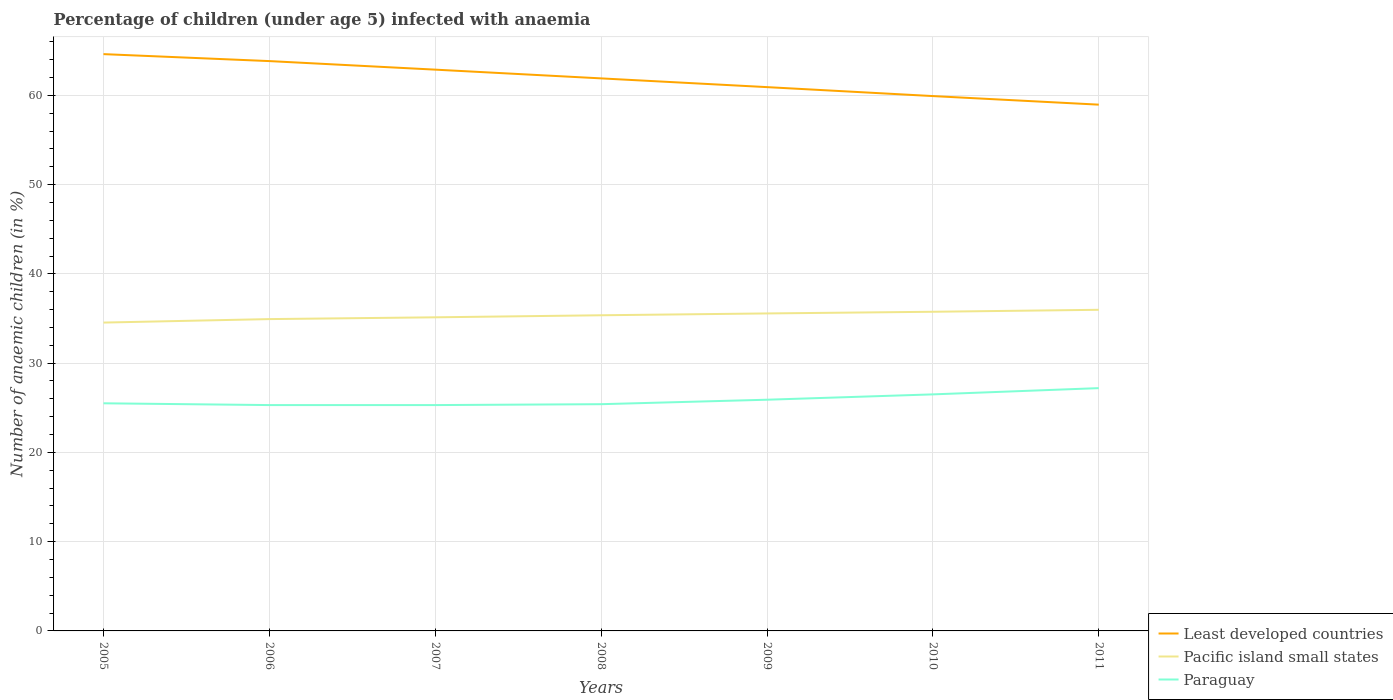How many different coloured lines are there?
Your response must be concise. 3. Does the line corresponding to Pacific island small states intersect with the line corresponding to Paraguay?
Offer a very short reply. No. Is the number of lines equal to the number of legend labels?
Make the answer very short. Yes. Across all years, what is the maximum percentage of children infected with anaemia in in Least developed countries?
Give a very brief answer. 58.96. In which year was the percentage of children infected with anaemia in in Pacific island small states maximum?
Provide a short and direct response. 2005. What is the total percentage of children infected with anaemia in in Paraguay in the graph?
Give a very brief answer. -0.1. What is the difference between the highest and the second highest percentage of children infected with anaemia in in Least developed countries?
Your answer should be compact. 5.66. What is the difference between the highest and the lowest percentage of children infected with anaemia in in Least developed countries?
Make the answer very short. 4. How many lines are there?
Provide a short and direct response. 3. How many years are there in the graph?
Your answer should be compact. 7. What is the difference between two consecutive major ticks on the Y-axis?
Provide a succinct answer. 10. Are the values on the major ticks of Y-axis written in scientific E-notation?
Provide a succinct answer. No. Does the graph contain any zero values?
Make the answer very short. No. Does the graph contain grids?
Your response must be concise. Yes. How many legend labels are there?
Provide a succinct answer. 3. What is the title of the graph?
Your response must be concise. Percentage of children (under age 5) infected with anaemia. Does "Barbados" appear as one of the legend labels in the graph?
Give a very brief answer. No. What is the label or title of the Y-axis?
Offer a very short reply. Number of anaemic children (in %). What is the Number of anaemic children (in %) of Least developed countries in 2005?
Provide a short and direct response. 64.62. What is the Number of anaemic children (in %) of Pacific island small states in 2005?
Your response must be concise. 34.54. What is the Number of anaemic children (in %) of Least developed countries in 2006?
Offer a very short reply. 63.84. What is the Number of anaemic children (in %) of Pacific island small states in 2006?
Make the answer very short. 34.93. What is the Number of anaemic children (in %) in Paraguay in 2006?
Your response must be concise. 25.3. What is the Number of anaemic children (in %) of Least developed countries in 2007?
Your response must be concise. 62.88. What is the Number of anaemic children (in %) in Pacific island small states in 2007?
Offer a very short reply. 35.13. What is the Number of anaemic children (in %) of Paraguay in 2007?
Your answer should be compact. 25.3. What is the Number of anaemic children (in %) of Least developed countries in 2008?
Keep it short and to the point. 61.9. What is the Number of anaemic children (in %) in Pacific island small states in 2008?
Give a very brief answer. 35.36. What is the Number of anaemic children (in %) of Paraguay in 2008?
Your answer should be very brief. 25.4. What is the Number of anaemic children (in %) of Least developed countries in 2009?
Your answer should be compact. 60.92. What is the Number of anaemic children (in %) in Pacific island small states in 2009?
Ensure brevity in your answer.  35.57. What is the Number of anaemic children (in %) in Paraguay in 2009?
Provide a short and direct response. 25.9. What is the Number of anaemic children (in %) in Least developed countries in 2010?
Ensure brevity in your answer.  59.92. What is the Number of anaemic children (in %) of Pacific island small states in 2010?
Your answer should be compact. 35.75. What is the Number of anaemic children (in %) of Paraguay in 2010?
Ensure brevity in your answer.  26.5. What is the Number of anaemic children (in %) of Least developed countries in 2011?
Give a very brief answer. 58.96. What is the Number of anaemic children (in %) in Pacific island small states in 2011?
Provide a short and direct response. 35.97. What is the Number of anaemic children (in %) of Paraguay in 2011?
Your answer should be very brief. 27.2. Across all years, what is the maximum Number of anaemic children (in %) in Least developed countries?
Make the answer very short. 64.62. Across all years, what is the maximum Number of anaemic children (in %) in Pacific island small states?
Ensure brevity in your answer.  35.97. Across all years, what is the maximum Number of anaemic children (in %) of Paraguay?
Your response must be concise. 27.2. Across all years, what is the minimum Number of anaemic children (in %) in Least developed countries?
Provide a short and direct response. 58.96. Across all years, what is the minimum Number of anaemic children (in %) of Pacific island small states?
Provide a succinct answer. 34.54. Across all years, what is the minimum Number of anaemic children (in %) in Paraguay?
Ensure brevity in your answer.  25.3. What is the total Number of anaemic children (in %) of Least developed countries in the graph?
Offer a very short reply. 433.02. What is the total Number of anaemic children (in %) in Pacific island small states in the graph?
Keep it short and to the point. 247.26. What is the total Number of anaemic children (in %) of Paraguay in the graph?
Offer a terse response. 181.1. What is the difference between the Number of anaemic children (in %) of Least developed countries in 2005 and that in 2006?
Offer a terse response. 0.78. What is the difference between the Number of anaemic children (in %) in Pacific island small states in 2005 and that in 2006?
Make the answer very short. -0.39. What is the difference between the Number of anaemic children (in %) in Paraguay in 2005 and that in 2006?
Keep it short and to the point. 0.2. What is the difference between the Number of anaemic children (in %) in Least developed countries in 2005 and that in 2007?
Provide a short and direct response. 1.74. What is the difference between the Number of anaemic children (in %) in Pacific island small states in 2005 and that in 2007?
Ensure brevity in your answer.  -0.59. What is the difference between the Number of anaemic children (in %) in Least developed countries in 2005 and that in 2008?
Provide a short and direct response. 2.72. What is the difference between the Number of anaemic children (in %) in Pacific island small states in 2005 and that in 2008?
Your answer should be compact. -0.82. What is the difference between the Number of anaemic children (in %) in Paraguay in 2005 and that in 2008?
Offer a very short reply. 0.1. What is the difference between the Number of anaemic children (in %) of Least developed countries in 2005 and that in 2009?
Your answer should be very brief. 3.7. What is the difference between the Number of anaemic children (in %) of Pacific island small states in 2005 and that in 2009?
Provide a succinct answer. -1.03. What is the difference between the Number of anaemic children (in %) in Paraguay in 2005 and that in 2009?
Your answer should be compact. -0.4. What is the difference between the Number of anaemic children (in %) in Least developed countries in 2005 and that in 2010?
Offer a very short reply. 4.7. What is the difference between the Number of anaemic children (in %) of Pacific island small states in 2005 and that in 2010?
Give a very brief answer. -1.21. What is the difference between the Number of anaemic children (in %) of Paraguay in 2005 and that in 2010?
Provide a succinct answer. -1. What is the difference between the Number of anaemic children (in %) of Least developed countries in 2005 and that in 2011?
Your response must be concise. 5.66. What is the difference between the Number of anaemic children (in %) in Pacific island small states in 2005 and that in 2011?
Offer a terse response. -1.43. What is the difference between the Number of anaemic children (in %) of Paraguay in 2005 and that in 2011?
Your response must be concise. -1.7. What is the difference between the Number of anaemic children (in %) of Least developed countries in 2006 and that in 2007?
Offer a terse response. 0.96. What is the difference between the Number of anaemic children (in %) of Pacific island small states in 2006 and that in 2007?
Give a very brief answer. -0.2. What is the difference between the Number of anaemic children (in %) of Paraguay in 2006 and that in 2007?
Provide a succinct answer. 0. What is the difference between the Number of anaemic children (in %) in Least developed countries in 2006 and that in 2008?
Offer a very short reply. 1.94. What is the difference between the Number of anaemic children (in %) in Pacific island small states in 2006 and that in 2008?
Provide a short and direct response. -0.43. What is the difference between the Number of anaemic children (in %) of Paraguay in 2006 and that in 2008?
Offer a very short reply. -0.1. What is the difference between the Number of anaemic children (in %) of Least developed countries in 2006 and that in 2009?
Give a very brief answer. 2.92. What is the difference between the Number of anaemic children (in %) of Pacific island small states in 2006 and that in 2009?
Provide a short and direct response. -0.63. What is the difference between the Number of anaemic children (in %) of Paraguay in 2006 and that in 2009?
Provide a short and direct response. -0.6. What is the difference between the Number of anaemic children (in %) of Least developed countries in 2006 and that in 2010?
Your answer should be compact. 3.92. What is the difference between the Number of anaemic children (in %) in Pacific island small states in 2006 and that in 2010?
Provide a short and direct response. -0.82. What is the difference between the Number of anaemic children (in %) of Paraguay in 2006 and that in 2010?
Your response must be concise. -1.2. What is the difference between the Number of anaemic children (in %) of Least developed countries in 2006 and that in 2011?
Ensure brevity in your answer.  4.88. What is the difference between the Number of anaemic children (in %) of Pacific island small states in 2006 and that in 2011?
Offer a terse response. -1.04. What is the difference between the Number of anaemic children (in %) in Least developed countries in 2007 and that in 2008?
Provide a succinct answer. 0.98. What is the difference between the Number of anaemic children (in %) in Pacific island small states in 2007 and that in 2008?
Your response must be concise. -0.23. What is the difference between the Number of anaemic children (in %) of Paraguay in 2007 and that in 2008?
Provide a succinct answer. -0.1. What is the difference between the Number of anaemic children (in %) in Least developed countries in 2007 and that in 2009?
Your response must be concise. 1.96. What is the difference between the Number of anaemic children (in %) of Pacific island small states in 2007 and that in 2009?
Offer a terse response. -0.43. What is the difference between the Number of anaemic children (in %) in Least developed countries in 2007 and that in 2010?
Keep it short and to the point. 2.96. What is the difference between the Number of anaemic children (in %) of Pacific island small states in 2007 and that in 2010?
Ensure brevity in your answer.  -0.62. What is the difference between the Number of anaemic children (in %) in Paraguay in 2007 and that in 2010?
Ensure brevity in your answer.  -1.2. What is the difference between the Number of anaemic children (in %) of Least developed countries in 2007 and that in 2011?
Keep it short and to the point. 3.92. What is the difference between the Number of anaemic children (in %) in Pacific island small states in 2007 and that in 2011?
Your response must be concise. -0.84. What is the difference between the Number of anaemic children (in %) in Paraguay in 2007 and that in 2011?
Your response must be concise. -1.9. What is the difference between the Number of anaemic children (in %) in Least developed countries in 2008 and that in 2009?
Your answer should be compact. 0.98. What is the difference between the Number of anaemic children (in %) in Pacific island small states in 2008 and that in 2009?
Your answer should be compact. -0.21. What is the difference between the Number of anaemic children (in %) in Paraguay in 2008 and that in 2009?
Make the answer very short. -0.5. What is the difference between the Number of anaemic children (in %) in Least developed countries in 2008 and that in 2010?
Ensure brevity in your answer.  1.98. What is the difference between the Number of anaemic children (in %) of Pacific island small states in 2008 and that in 2010?
Keep it short and to the point. -0.39. What is the difference between the Number of anaemic children (in %) of Paraguay in 2008 and that in 2010?
Your response must be concise. -1.1. What is the difference between the Number of anaemic children (in %) in Least developed countries in 2008 and that in 2011?
Your response must be concise. 2.94. What is the difference between the Number of anaemic children (in %) of Pacific island small states in 2008 and that in 2011?
Provide a short and direct response. -0.61. What is the difference between the Number of anaemic children (in %) in Paraguay in 2008 and that in 2011?
Offer a very short reply. -1.8. What is the difference between the Number of anaemic children (in %) in Pacific island small states in 2009 and that in 2010?
Offer a terse response. -0.19. What is the difference between the Number of anaemic children (in %) of Least developed countries in 2009 and that in 2011?
Provide a short and direct response. 1.96. What is the difference between the Number of anaemic children (in %) in Pacific island small states in 2009 and that in 2011?
Offer a terse response. -0.41. What is the difference between the Number of anaemic children (in %) in Paraguay in 2009 and that in 2011?
Your answer should be very brief. -1.3. What is the difference between the Number of anaemic children (in %) of Least developed countries in 2010 and that in 2011?
Offer a terse response. 0.96. What is the difference between the Number of anaemic children (in %) in Pacific island small states in 2010 and that in 2011?
Provide a succinct answer. -0.22. What is the difference between the Number of anaemic children (in %) in Least developed countries in 2005 and the Number of anaemic children (in %) in Pacific island small states in 2006?
Make the answer very short. 29.68. What is the difference between the Number of anaemic children (in %) of Least developed countries in 2005 and the Number of anaemic children (in %) of Paraguay in 2006?
Give a very brief answer. 39.32. What is the difference between the Number of anaemic children (in %) of Pacific island small states in 2005 and the Number of anaemic children (in %) of Paraguay in 2006?
Ensure brevity in your answer.  9.24. What is the difference between the Number of anaemic children (in %) of Least developed countries in 2005 and the Number of anaemic children (in %) of Pacific island small states in 2007?
Offer a very short reply. 29.48. What is the difference between the Number of anaemic children (in %) of Least developed countries in 2005 and the Number of anaemic children (in %) of Paraguay in 2007?
Offer a terse response. 39.32. What is the difference between the Number of anaemic children (in %) of Pacific island small states in 2005 and the Number of anaemic children (in %) of Paraguay in 2007?
Offer a very short reply. 9.24. What is the difference between the Number of anaemic children (in %) of Least developed countries in 2005 and the Number of anaemic children (in %) of Pacific island small states in 2008?
Give a very brief answer. 29.26. What is the difference between the Number of anaemic children (in %) of Least developed countries in 2005 and the Number of anaemic children (in %) of Paraguay in 2008?
Give a very brief answer. 39.22. What is the difference between the Number of anaemic children (in %) of Pacific island small states in 2005 and the Number of anaemic children (in %) of Paraguay in 2008?
Make the answer very short. 9.14. What is the difference between the Number of anaemic children (in %) of Least developed countries in 2005 and the Number of anaemic children (in %) of Pacific island small states in 2009?
Offer a very short reply. 29.05. What is the difference between the Number of anaemic children (in %) of Least developed countries in 2005 and the Number of anaemic children (in %) of Paraguay in 2009?
Provide a short and direct response. 38.72. What is the difference between the Number of anaemic children (in %) in Pacific island small states in 2005 and the Number of anaemic children (in %) in Paraguay in 2009?
Make the answer very short. 8.64. What is the difference between the Number of anaemic children (in %) in Least developed countries in 2005 and the Number of anaemic children (in %) in Pacific island small states in 2010?
Offer a very short reply. 28.86. What is the difference between the Number of anaemic children (in %) in Least developed countries in 2005 and the Number of anaemic children (in %) in Paraguay in 2010?
Ensure brevity in your answer.  38.12. What is the difference between the Number of anaemic children (in %) of Pacific island small states in 2005 and the Number of anaemic children (in %) of Paraguay in 2010?
Keep it short and to the point. 8.04. What is the difference between the Number of anaemic children (in %) in Least developed countries in 2005 and the Number of anaemic children (in %) in Pacific island small states in 2011?
Give a very brief answer. 28.64. What is the difference between the Number of anaemic children (in %) in Least developed countries in 2005 and the Number of anaemic children (in %) in Paraguay in 2011?
Your response must be concise. 37.42. What is the difference between the Number of anaemic children (in %) in Pacific island small states in 2005 and the Number of anaemic children (in %) in Paraguay in 2011?
Keep it short and to the point. 7.34. What is the difference between the Number of anaemic children (in %) of Least developed countries in 2006 and the Number of anaemic children (in %) of Pacific island small states in 2007?
Give a very brief answer. 28.7. What is the difference between the Number of anaemic children (in %) of Least developed countries in 2006 and the Number of anaemic children (in %) of Paraguay in 2007?
Give a very brief answer. 38.54. What is the difference between the Number of anaemic children (in %) in Pacific island small states in 2006 and the Number of anaemic children (in %) in Paraguay in 2007?
Make the answer very short. 9.63. What is the difference between the Number of anaemic children (in %) of Least developed countries in 2006 and the Number of anaemic children (in %) of Pacific island small states in 2008?
Ensure brevity in your answer.  28.47. What is the difference between the Number of anaemic children (in %) of Least developed countries in 2006 and the Number of anaemic children (in %) of Paraguay in 2008?
Give a very brief answer. 38.44. What is the difference between the Number of anaemic children (in %) of Pacific island small states in 2006 and the Number of anaemic children (in %) of Paraguay in 2008?
Offer a terse response. 9.53. What is the difference between the Number of anaemic children (in %) in Least developed countries in 2006 and the Number of anaemic children (in %) in Pacific island small states in 2009?
Your answer should be compact. 28.27. What is the difference between the Number of anaemic children (in %) of Least developed countries in 2006 and the Number of anaemic children (in %) of Paraguay in 2009?
Make the answer very short. 37.94. What is the difference between the Number of anaemic children (in %) of Pacific island small states in 2006 and the Number of anaemic children (in %) of Paraguay in 2009?
Provide a succinct answer. 9.03. What is the difference between the Number of anaemic children (in %) of Least developed countries in 2006 and the Number of anaemic children (in %) of Pacific island small states in 2010?
Give a very brief answer. 28.08. What is the difference between the Number of anaemic children (in %) in Least developed countries in 2006 and the Number of anaemic children (in %) in Paraguay in 2010?
Keep it short and to the point. 37.34. What is the difference between the Number of anaemic children (in %) of Pacific island small states in 2006 and the Number of anaemic children (in %) of Paraguay in 2010?
Give a very brief answer. 8.43. What is the difference between the Number of anaemic children (in %) of Least developed countries in 2006 and the Number of anaemic children (in %) of Pacific island small states in 2011?
Provide a short and direct response. 27.86. What is the difference between the Number of anaemic children (in %) of Least developed countries in 2006 and the Number of anaemic children (in %) of Paraguay in 2011?
Offer a terse response. 36.64. What is the difference between the Number of anaemic children (in %) of Pacific island small states in 2006 and the Number of anaemic children (in %) of Paraguay in 2011?
Provide a succinct answer. 7.73. What is the difference between the Number of anaemic children (in %) of Least developed countries in 2007 and the Number of anaemic children (in %) of Pacific island small states in 2008?
Provide a short and direct response. 27.52. What is the difference between the Number of anaemic children (in %) in Least developed countries in 2007 and the Number of anaemic children (in %) in Paraguay in 2008?
Provide a short and direct response. 37.48. What is the difference between the Number of anaemic children (in %) in Pacific island small states in 2007 and the Number of anaemic children (in %) in Paraguay in 2008?
Offer a terse response. 9.73. What is the difference between the Number of anaemic children (in %) of Least developed countries in 2007 and the Number of anaemic children (in %) of Pacific island small states in 2009?
Your answer should be compact. 27.31. What is the difference between the Number of anaemic children (in %) of Least developed countries in 2007 and the Number of anaemic children (in %) of Paraguay in 2009?
Offer a very short reply. 36.98. What is the difference between the Number of anaemic children (in %) of Pacific island small states in 2007 and the Number of anaemic children (in %) of Paraguay in 2009?
Make the answer very short. 9.23. What is the difference between the Number of anaemic children (in %) in Least developed countries in 2007 and the Number of anaemic children (in %) in Pacific island small states in 2010?
Offer a terse response. 27.12. What is the difference between the Number of anaemic children (in %) of Least developed countries in 2007 and the Number of anaemic children (in %) of Paraguay in 2010?
Ensure brevity in your answer.  36.38. What is the difference between the Number of anaemic children (in %) in Pacific island small states in 2007 and the Number of anaemic children (in %) in Paraguay in 2010?
Give a very brief answer. 8.63. What is the difference between the Number of anaemic children (in %) in Least developed countries in 2007 and the Number of anaemic children (in %) in Pacific island small states in 2011?
Offer a terse response. 26.9. What is the difference between the Number of anaemic children (in %) in Least developed countries in 2007 and the Number of anaemic children (in %) in Paraguay in 2011?
Make the answer very short. 35.68. What is the difference between the Number of anaemic children (in %) of Pacific island small states in 2007 and the Number of anaemic children (in %) of Paraguay in 2011?
Provide a succinct answer. 7.93. What is the difference between the Number of anaemic children (in %) in Least developed countries in 2008 and the Number of anaemic children (in %) in Pacific island small states in 2009?
Ensure brevity in your answer.  26.33. What is the difference between the Number of anaemic children (in %) of Least developed countries in 2008 and the Number of anaemic children (in %) of Paraguay in 2009?
Make the answer very short. 36. What is the difference between the Number of anaemic children (in %) of Pacific island small states in 2008 and the Number of anaemic children (in %) of Paraguay in 2009?
Offer a terse response. 9.46. What is the difference between the Number of anaemic children (in %) in Least developed countries in 2008 and the Number of anaemic children (in %) in Pacific island small states in 2010?
Your answer should be very brief. 26.15. What is the difference between the Number of anaemic children (in %) in Least developed countries in 2008 and the Number of anaemic children (in %) in Paraguay in 2010?
Keep it short and to the point. 35.4. What is the difference between the Number of anaemic children (in %) in Pacific island small states in 2008 and the Number of anaemic children (in %) in Paraguay in 2010?
Make the answer very short. 8.86. What is the difference between the Number of anaemic children (in %) in Least developed countries in 2008 and the Number of anaemic children (in %) in Pacific island small states in 2011?
Offer a very short reply. 25.93. What is the difference between the Number of anaemic children (in %) of Least developed countries in 2008 and the Number of anaemic children (in %) of Paraguay in 2011?
Offer a very short reply. 34.7. What is the difference between the Number of anaemic children (in %) in Pacific island small states in 2008 and the Number of anaemic children (in %) in Paraguay in 2011?
Your answer should be compact. 8.16. What is the difference between the Number of anaemic children (in %) of Least developed countries in 2009 and the Number of anaemic children (in %) of Pacific island small states in 2010?
Provide a succinct answer. 25.17. What is the difference between the Number of anaemic children (in %) in Least developed countries in 2009 and the Number of anaemic children (in %) in Paraguay in 2010?
Your answer should be very brief. 34.42. What is the difference between the Number of anaemic children (in %) of Pacific island small states in 2009 and the Number of anaemic children (in %) of Paraguay in 2010?
Offer a very short reply. 9.07. What is the difference between the Number of anaemic children (in %) of Least developed countries in 2009 and the Number of anaemic children (in %) of Pacific island small states in 2011?
Offer a very short reply. 24.95. What is the difference between the Number of anaemic children (in %) in Least developed countries in 2009 and the Number of anaemic children (in %) in Paraguay in 2011?
Your response must be concise. 33.72. What is the difference between the Number of anaemic children (in %) in Pacific island small states in 2009 and the Number of anaemic children (in %) in Paraguay in 2011?
Your answer should be compact. 8.37. What is the difference between the Number of anaemic children (in %) of Least developed countries in 2010 and the Number of anaemic children (in %) of Pacific island small states in 2011?
Offer a very short reply. 23.94. What is the difference between the Number of anaemic children (in %) in Least developed countries in 2010 and the Number of anaemic children (in %) in Paraguay in 2011?
Keep it short and to the point. 32.72. What is the difference between the Number of anaemic children (in %) in Pacific island small states in 2010 and the Number of anaemic children (in %) in Paraguay in 2011?
Provide a short and direct response. 8.55. What is the average Number of anaemic children (in %) in Least developed countries per year?
Your answer should be very brief. 61.86. What is the average Number of anaemic children (in %) of Pacific island small states per year?
Give a very brief answer. 35.32. What is the average Number of anaemic children (in %) of Paraguay per year?
Your response must be concise. 25.87. In the year 2005, what is the difference between the Number of anaemic children (in %) of Least developed countries and Number of anaemic children (in %) of Pacific island small states?
Offer a very short reply. 30.07. In the year 2005, what is the difference between the Number of anaemic children (in %) in Least developed countries and Number of anaemic children (in %) in Paraguay?
Provide a succinct answer. 39.12. In the year 2005, what is the difference between the Number of anaemic children (in %) in Pacific island small states and Number of anaemic children (in %) in Paraguay?
Provide a succinct answer. 9.04. In the year 2006, what is the difference between the Number of anaemic children (in %) in Least developed countries and Number of anaemic children (in %) in Pacific island small states?
Your response must be concise. 28.9. In the year 2006, what is the difference between the Number of anaemic children (in %) of Least developed countries and Number of anaemic children (in %) of Paraguay?
Provide a succinct answer. 38.54. In the year 2006, what is the difference between the Number of anaemic children (in %) of Pacific island small states and Number of anaemic children (in %) of Paraguay?
Your response must be concise. 9.63. In the year 2007, what is the difference between the Number of anaemic children (in %) of Least developed countries and Number of anaemic children (in %) of Pacific island small states?
Your answer should be compact. 27.75. In the year 2007, what is the difference between the Number of anaemic children (in %) in Least developed countries and Number of anaemic children (in %) in Paraguay?
Offer a very short reply. 37.58. In the year 2007, what is the difference between the Number of anaemic children (in %) of Pacific island small states and Number of anaemic children (in %) of Paraguay?
Your answer should be compact. 9.83. In the year 2008, what is the difference between the Number of anaemic children (in %) of Least developed countries and Number of anaemic children (in %) of Pacific island small states?
Provide a succinct answer. 26.54. In the year 2008, what is the difference between the Number of anaemic children (in %) of Least developed countries and Number of anaemic children (in %) of Paraguay?
Provide a short and direct response. 36.5. In the year 2008, what is the difference between the Number of anaemic children (in %) of Pacific island small states and Number of anaemic children (in %) of Paraguay?
Provide a short and direct response. 9.96. In the year 2009, what is the difference between the Number of anaemic children (in %) in Least developed countries and Number of anaemic children (in %) in Pacific island small states?
Provide a succinct answer. 25.35. In the year 2009, what is the difference between the Number of anaemic children (in %) of Least developed countries and Number of anaemic children (in %) of Paraguay?
Offer a very short reply. 35.02. In the year 2009, what is the difference between the Number of anaemic children (in %) of Pacific island small states and Number of anaemic children (in %) of Paraguay?
Give a very brief answer. 9.67. In the year 2010, what is the difference between the Number of anaemic children (in %) in Least developed countries and Number of anaemic children (in %) in Pacific island small states?
Keep it short and to the point. 24.16. In the year 2010, what is the difference between the Number of anaemic children (in %) in Least developed countries and Number of anaemic children (in %) in Paraguay?
Ensure brevity in your answer.  33.42. In the year 2010, what is the difference between the Number of anaemic children (in %) of Pacific island small states and Number of anaemic children (in %) of Paraguay?
Your answer should be compact. 9.25. In the year 2011, what is the difference between the Number of anaemic children (in %) in Least developed countries and Number of anaemic children (in %) in Pacific island small states?
Your answer should be compact. 22.98. In the year 2011, what is the difference between the Number of anaemic children (in %) of Least developed countries and Number of anaemic children (in %) of Paraguay?
Ensure brevity in your answer.  31.76. In the year 2011, what is the difference between the Number of anaemic children (in %) of Pacific island small states and Number of anaemic children (in %) of Paraguay?
Provide a short and direct response. 8.77. What is the ratio of the Number of anaemic children (in %) in Least developed countries in 2005 to that in 2006?
Your answer should be very brief. 1.01. What is the ratio of the Number of anaemic children (in %) in Paraguay in 2005 to that in 2006?
Offer a terse response. 1.01. What is the ratio of the Number of anaemic children (in %) in Least developed countries in 2005 to that in 2007?
Give a very brief answer. 1.03. What is the ratio of the Number of anaemic children (in %) in Pacific island small states in 2005 to that in 2007?
Offer a terse response. 0.98. What is the ratio of the Number of anaemic children (in %) of Paraguay in 2005 to that in 2007?
Provide a short and direct response. 1.01. What is the ratio of the Number of anaemic children (in %) of Least developed countries in 2005 to that in 2008?
Your response must be concise. 1.04. What is the ratio of the Number of anaemic children (in %) in Pacific island small states in 2005 to that in 2008?
Your answer should be compact. 0.98. What is the ratio of the Number of anaemic children (in %) of Paraguay in 2005 to that in 2008?
Your response must be concise. 1. What is the ratio of the Number of anaemic children (in %) in Least developed countries in 2005 to that in 2009?
Provide a succinct answer. 1.06. What is the ratio of the Number of anaemic children (in %) in Pacific island small states in 2005 to that in 2009?
Ensure brevity in your answer.  0.97. What is the ratio of the Number of anaemic children (in %) of Paraguay in 2005 to that in 2009?
Offer a terse response. 0.98. What is the ratio of the Number of anaemic children (in %) of Least developed countries in 2005 to that in 2010?
Give a very brief answer. 1.08. What is the ratio of the Number of anaemic children (in %) in Pacific island small states in 2005 to that in 2010?
Your answer should be very brief. 0.97. What is the ratio of the Number of anaemic children (in %) of Paraguay in 2005 to that in 2010?
Provide a succinct answer. 0.96. What is the ratio of the Number of anaemic children (in %) of Least developed countries in 2005 to that in 2011?
Provide a short and direct response. 1.1. What is the ratio of the Number of anaemic children (in %) in Pacific island small states in 2005 to that in 2011?
Offer a terse response. 0.96. What is the ratio of the Number of anaemic children (in %) in Least developed countries in 2006 to that in 2007?
Ensure brevity in your answer.  1.02. What is the ratio of the Number of anaemic children (in %) in Pacific island small states in 2006 to that in 2007?
Your answer should be compact. 0.99. What is the ratio of the Number of anaemic children (in %) of Least developed countries in 2006 to that in 2008?
Ensure brevity in your answer.  1.03. What is the ratio of the Number of anaemic children (in %) in Pacific island small states in 2006 to that in 2008?
Provide a short and direct response. 0.99. What is the ratio of the Number of anaemic children (in %) of Paraguay in 2006 to that in 2008?
Provide a succinct answer. 1. What is the ratio of the Number of anaemic children (in %) in Least developed countries in 2006 to that in 2009?
Your answer should be compact. 1.05. What is the ratio of the Number of anaemic children (in %) of Pacific island small states in 2006 to that in 2009?
Your answer should be compact. 0.98. What is the ratio of the Number of anaemic children (in %) of Paraguay in 2006 to that in 2009?
Offer a very short reply. 0.98. What is the ratio of the Number of anaemic children (in %) of Least developed countries in 2006 to that in 2010?
Your response must be concise. 1.07. What is the ratio of the Number of anaemic children (in %) in Pacific island small states in 2006 to that in 2010?
Your answer should be very brief. 0.98. What is the ratio of the Number of anaemic children (in %) in Paraguay in 2006 to that in 2010?
Give a very brief answer. 0.95. What is the ratio of the Number of anaemic children (in %) in Least developed countries in 2006 to that in 2011?
Offer a terse response. 1.08. What is the ratio of the Number of anaemic children (in %) in Pacific island small states in 2006 to that in 2011?
Your response must be concise. 0.97. What is the ratio of the Number of anaemic children (in %) of Paraguay in 2006 to that in 2011?
Offer a terse response. 0.93. What is the ratio of the Number of anaemic children (in %) in Least developed countries in 2007 to that in 2008?
Your response must be concise. 1.02. What is the ratio of the Number of anaemic children (in %) in Paraguay in 2007 to that in 2008?
Ensure brevity in your answer.  1. What is the ratio of the Number of anaemic children (in %) in Least developed countries in 2007 to that in 2009?
Your answer should be compact. 1.03. What is the ratio of the Number of anaemic children (in %) in Pacific island small states in 2007 to that in 2009?
Make the answer very short. 0.99. What is the ratio of the Number of anaemic children (in %) of Paraguay in 2007 to that in 2009?
Offer a terse response. 0.98. What is the ratio of the Number of anaemic children (in %) of Least developed countries in 2007 to that in 2010?
Offer a very short reply. 1.05. What is the ratio of the Number of anaemic children (in %) in Pacific island small states in 2007 to that in 2010?
Your answer should be compact. 0.98. What is the ratio of the Number of anaemic children (in %) in Paraguay in 2007 to that in 2010?
Ensure brevity in your answer.  0.95. What is the ratio of the Number of anaemic children (in %) of Least developed countries in 2007 to that in 2011?
Offer a very short reply. 1.07. What is the ratio of the Number of anaemic children (in %) of Pacific island small states in 2007 to that in 2011?
Give a very brief answer. 0.98. What is the ratio of the Number of anaemic children (in %) in Paraguay in 2007 to that in 2011?
Make the answer very short. 0.93. What is the ratio of the Number of anaemic children (in %) of Least developed countries in 2008 to that in 2009?
Keep it short and to the point. 1.02. What is the ratio of the Number of anaemic children (in %) of Paraguay in 2008 to that in 2009?
Offer a very short reply. 0.98. What is the ratio of the Number of anaemic children (in %) of Least developed countries in 2008 to that in 2010?
Your answer should be very brief. 1.03. What is the ratio of the Number of anaemic children (in %) in Paraguay in 2008 to that in 2010?
Your answer should be very brief. 0.96. What is the ratio of the Number of anaemic children (in %) in Least developed countries in 2008 to that in 2011?
Provide a short and direct response. 1.05. What is the ratio of the Number of anaemic children (in %) in Pacific island small states in 2008 to that in 2011?
Offer a terse response. 0.98. What is the ratio of the Number of anaemic children (in %) in Paraguay in 2008 to that in 2011?
Keep it short and to the point. 0.93. What is the ratio of the Number of anaemic children (in %) of Least developed countries in 2009 to that in 2010?
Your answer should be compact. 1.02. What is the ratio of the Number of anaemic children (in %) of Paraguay in 2009 to that in 2010?
Ensure brevity in your answer.  0.98. What is the ratio of the Number of anaemic children (in %) in Least developed countries in 2009 to that in 2011?
Offer a very short reply. 1.03. What is the ratio of the Number of anaemic children (in %) of Pacific island small states in 2009 to that in 2011?
Your answer should be compact. 0.99. What is the ratio of the Number of anaemic children (in %) of Paraguay in 2009 to that in 2011?
Offer a very short reply. 0.95. What is the ratio of the Number of anaemic children (in %) of Least developed countries in 2010 to that in 2011?
Your answer should be very brief. 1.02. What is the ratio of the Number of anaemic children (in %) in Pacific island small states in 2010 to that in 2011?
Your answer should be very brief. 0.99. What is the ratio of the Number of anaemic children (in %) in Paraguay in 2010 to that in 2011?
Give a very brief answer. 0.97. What is the difference between the highest and the second highest Number of anaemic children (in %) in Least developed countries?
Keep it short and to the point. 0.78. What is the difference between the highest and the second highest Number of anaemic children (in %) of Pacific island small states?
Ensure brevity in your answer.  0.22. What is the difference between the highest and the lowest Number of anaemic children (in %) in Least developed countries?
Your answer should be compact. 5.66. What is the difference between the highest and the lowest Number of anaemic children (in %) of Pacific island small states?
Make the answer very short. 1.43. 